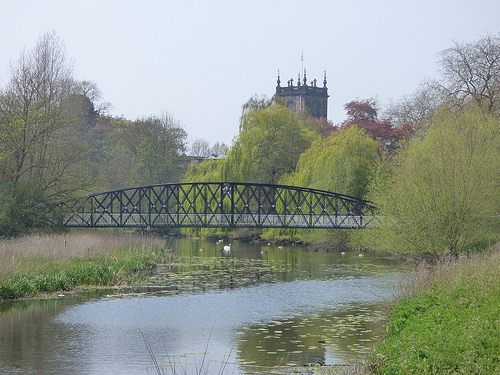<image>
Can you confirm if the bridge is behind the tree? Yes. From this viewpoint, the bridge is positioned behind the tree, with the tree partially or fully occluding the bridge. Is there a sky behind the building? Yes. From this viewpoint, the sky is positioned behind the building, with the building partially or fully occluding the sky. Where is the building in relation to the bridge? Is it in front of the bridge? No. The building is not in front of the bridge. The spatial positioning shows a different relationship between these objects. 